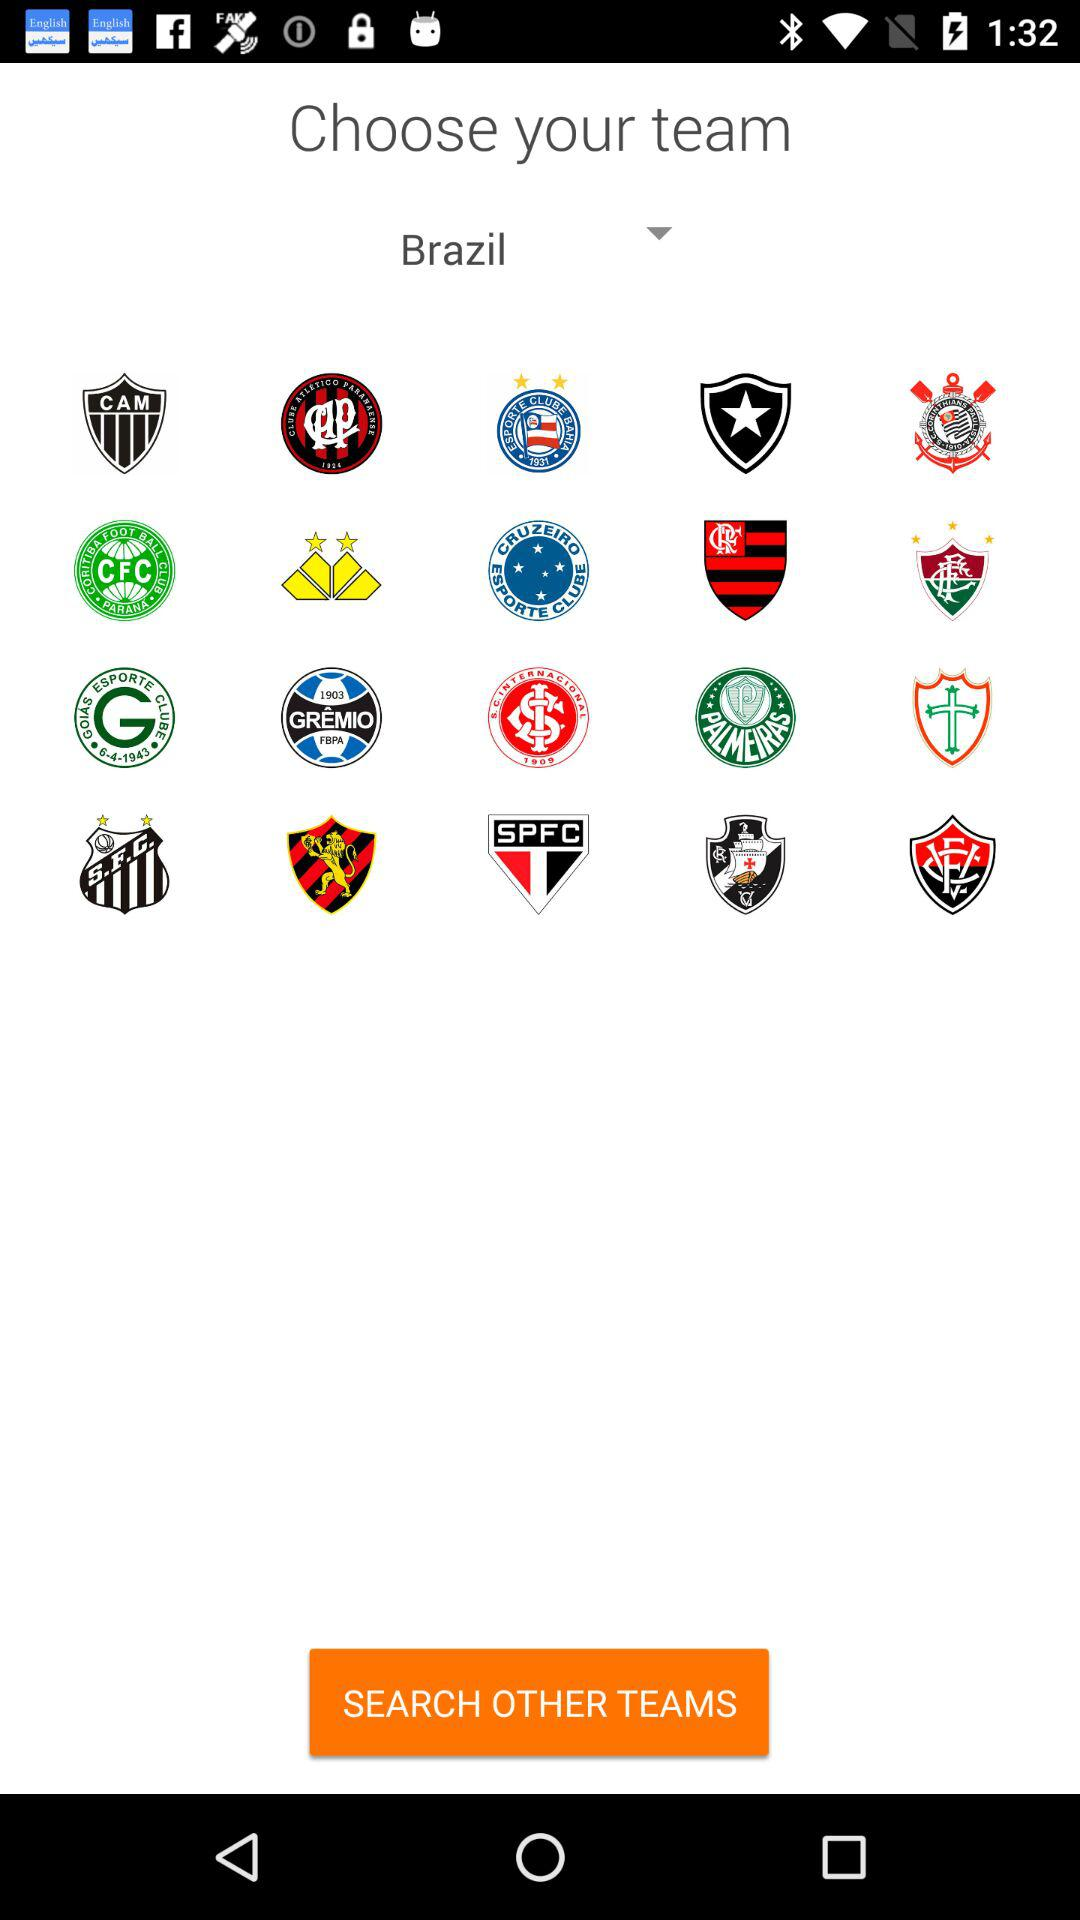What is the name of the chosen country for the team? The name of the chosen country is Brazil. 